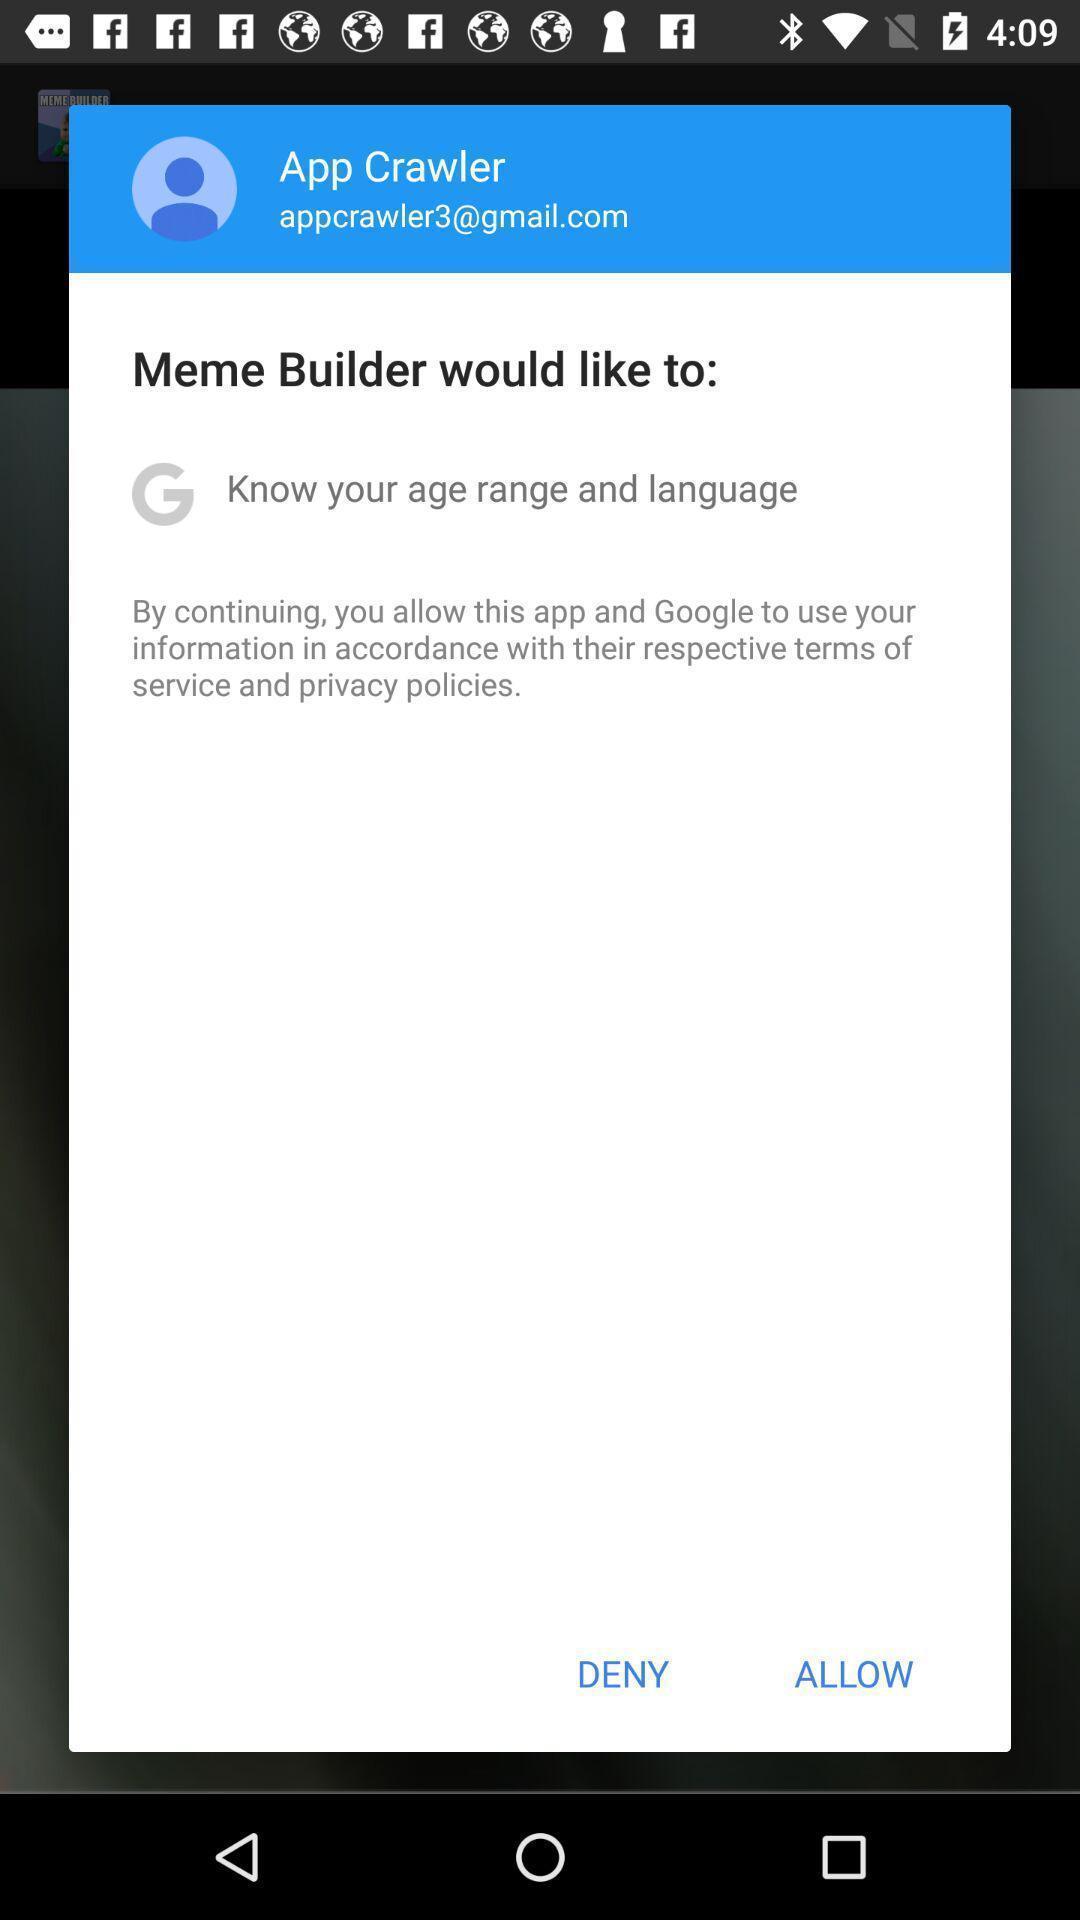Tell me about the visual elements in this screen capture. Pop-up displaying to continue in app. 